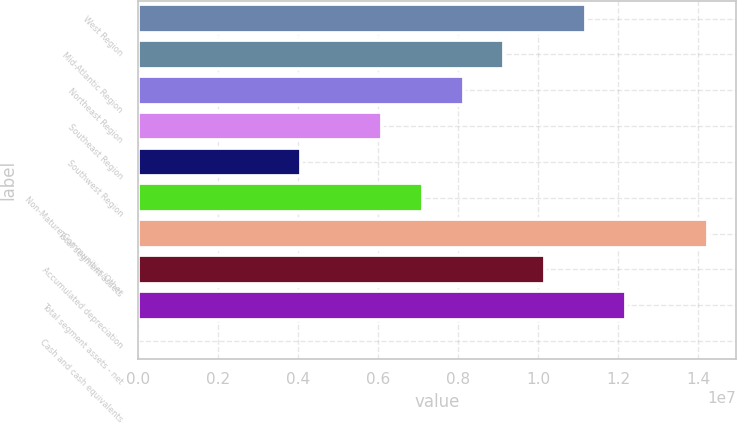Convert chart. <chart><loc_0><loc_0><loc_500><loc_500><bar_chart><fcel>West Region<fcel>Mid-Atlantic Region<fcel>Northeast Region<fcel>Southeast Region<fcel>Southwest Region<fcel>Non-Mature Communities/Other<fcel>Total segment assets<fcel>Accumulated depreciation<fcel>Total segment assets - net<fcel>Cash and cash equivalents<nl><fcel>1.11947e+07<fcel>9.15969e+06<fcel>8.14217e+06<fcel>6.10714e+06<fcel>4.07211e+06<fcel>7.12466e+06<fcel>1.42473e+07<fcel>1.01772e+07<fcel>1.22122e+07<fcel>2038<nl></chart> 